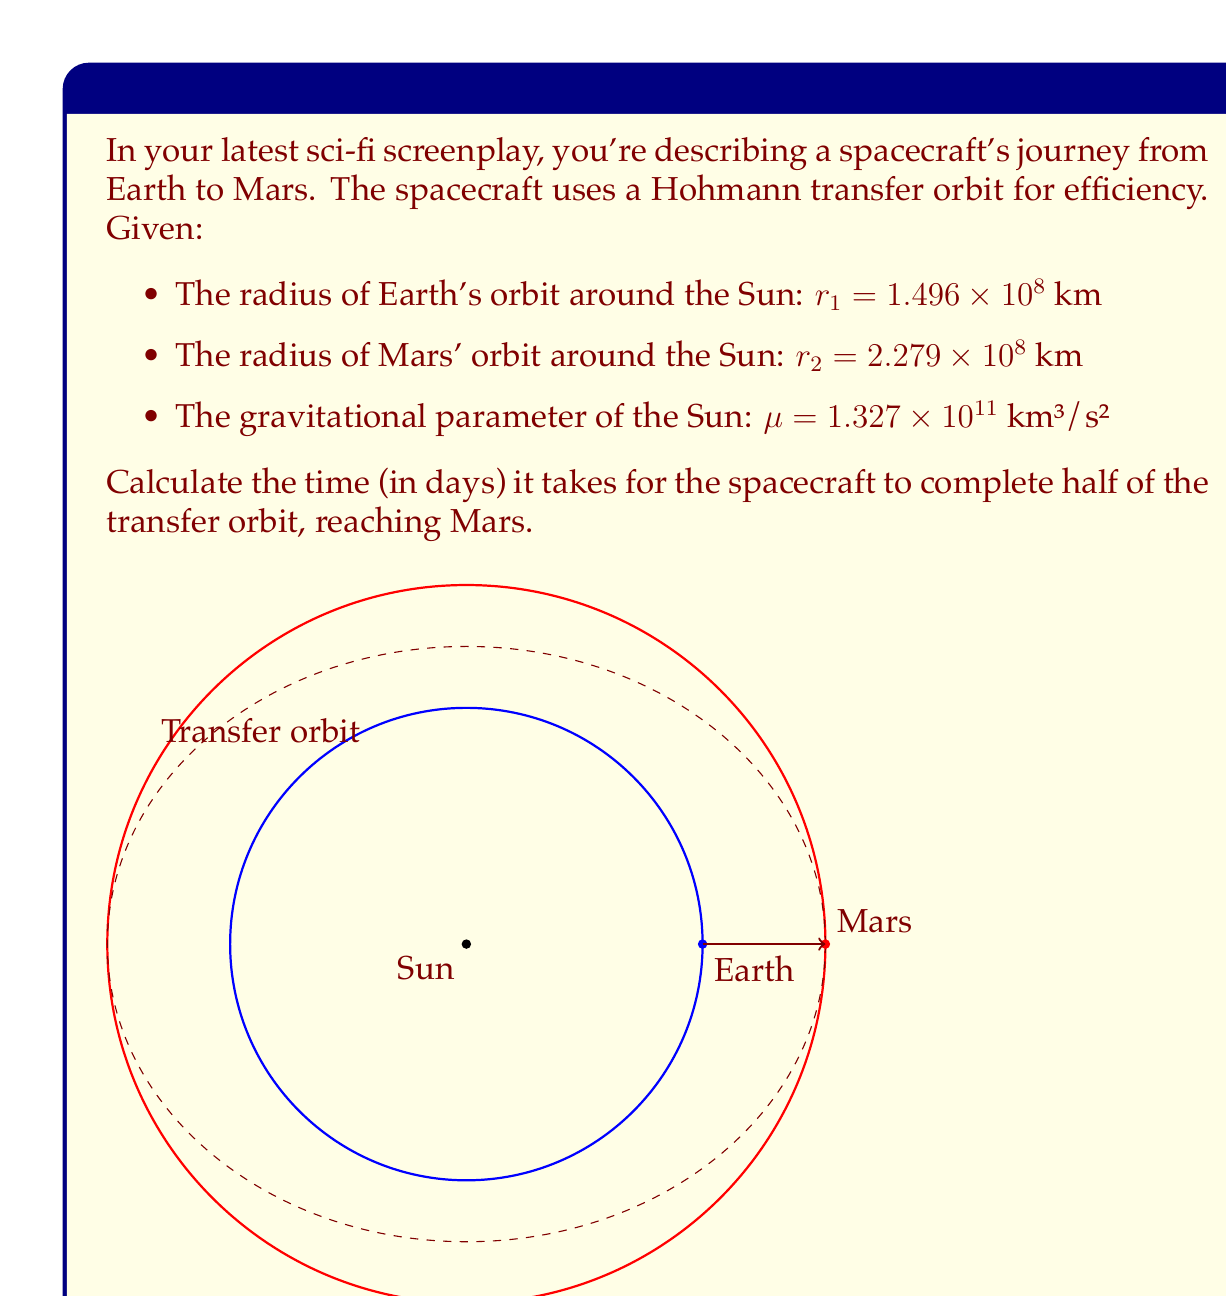Provide a solution to this math problem. To solve this problem, we'll use the principles of orbital mechanics and the Hohmann transfer orbit. Let's break it down step-by-step:

1) The semi-major axis of the transfer orbit is:

   $$a = \frac{r_1 + r_2}{2} = \frac{1.496 \times 10^8 + 2.279 \times 10^8}{2} = 1.8875 \times 10^8 \text{ km}$$

2) The period of an elliptical orbit is given by:

   $$T = 2\pi\sqrt{\frac{a^3}{\mu}}$$

3) Substituting our values:

   $$T = 2\pi\sqrt{\frac{(1.8875 \times 10^8)^3}{1.327 \times 10^{11}}}$$

4) Simplifying:

   $$T = 2\pi\sqrt{\frac{6.72985 \times 10^{24}}{1.327 \times 10^{11}}} = 2\pi\sqrt{5.07148 \times 10^{13}}$$

   $$T = 2\pi \times 7.121 \times 10^6 = 4.4733 \times 10^7 \text{ seconds}$$

5) The transfer time is half of this period:

   $$t = \frac{T}{2} = 2.23665 \times 10^7 \text{ seconds}$$

6) Converting to days:

   $$t = \frac{2.23665 \times 10^7}{86400} = 258.87 \text{ days}$$
Answer: 258.87 days 